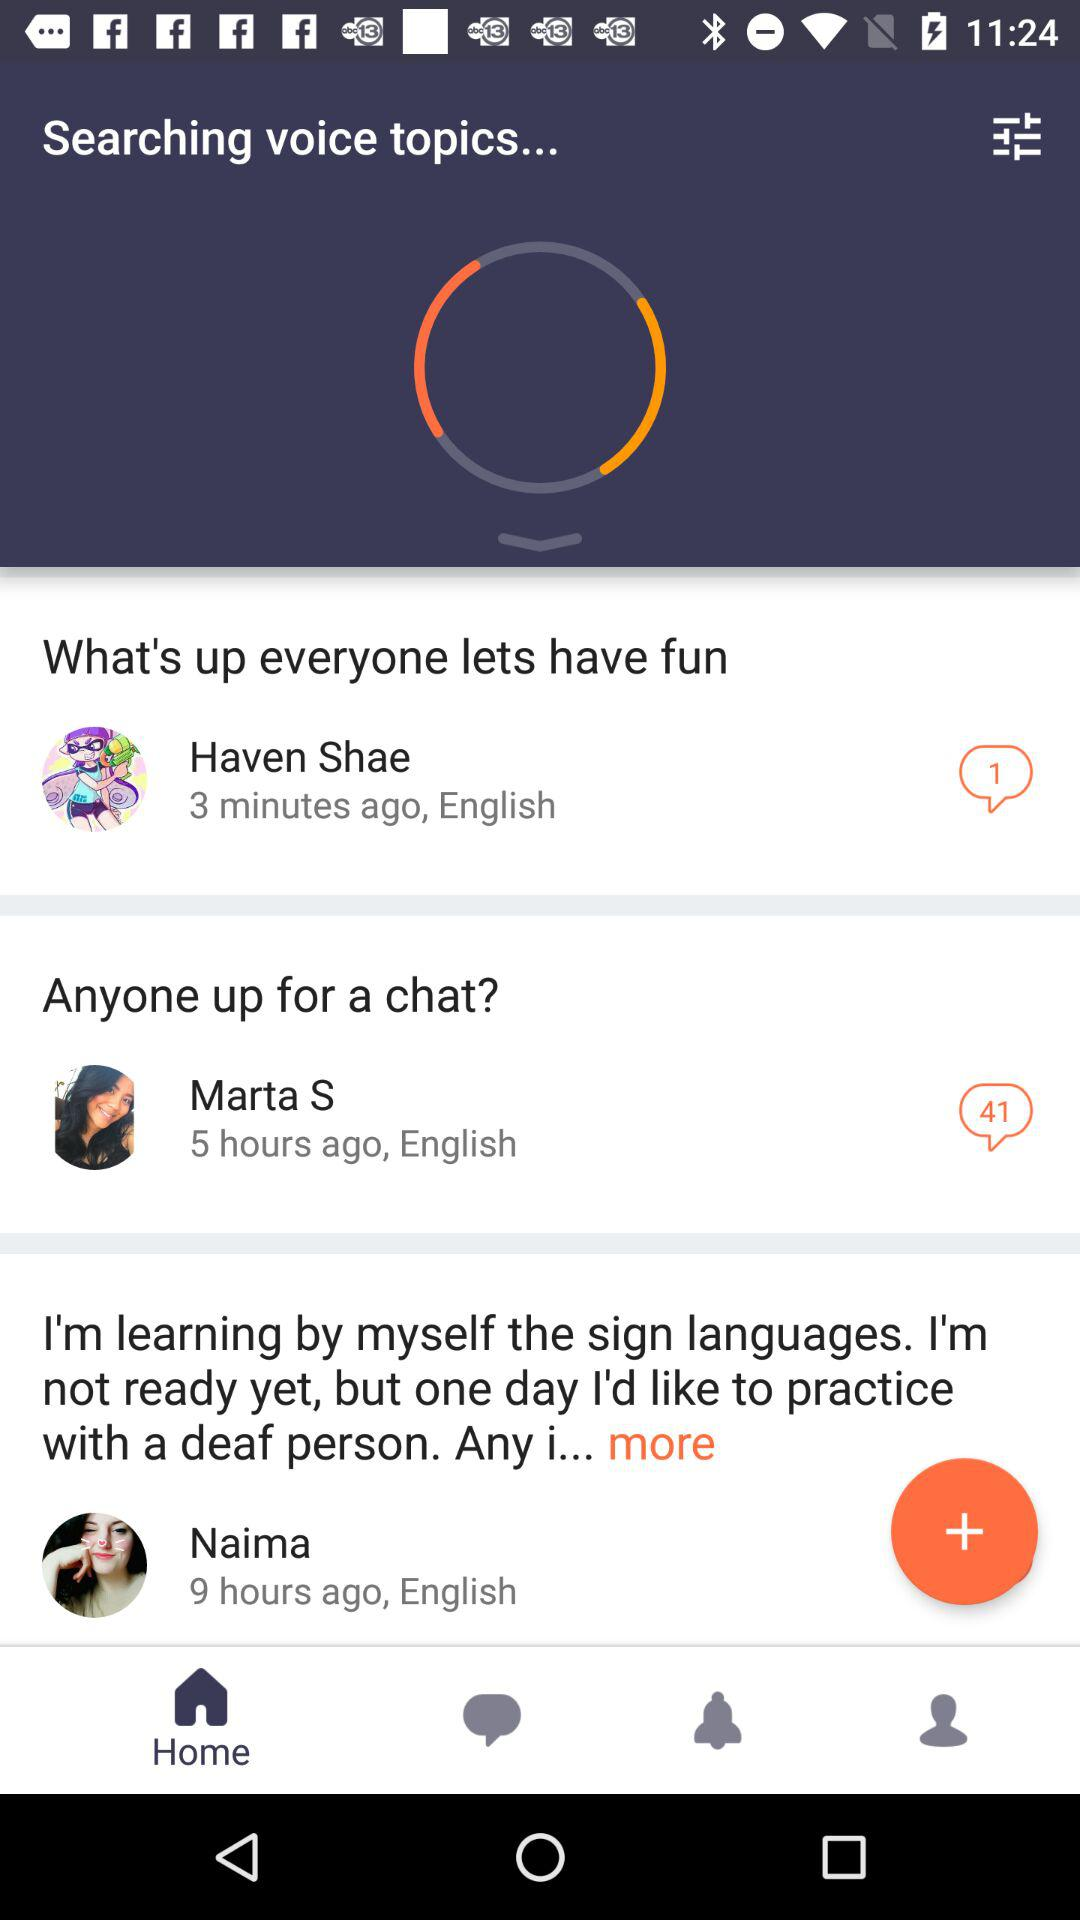When did Naima comment? Naima commented 9 hours ago. 